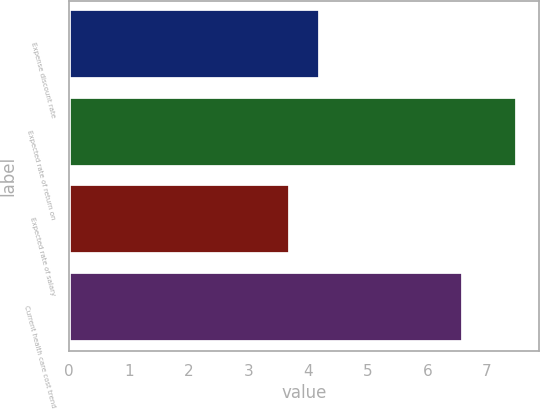Convert chart to OTSL. <chart><loc_0><loc_0><loc_500><loc_500><bar_chart><fcel>Expense discount rate<fcel>Expected rate of return on<fcel>Expected rate of salary<fcel>Current health care cost trend<nl><fcel>4.2<fcel>7.5<fcel>3.7<fcel>6.6<nl></chart> 